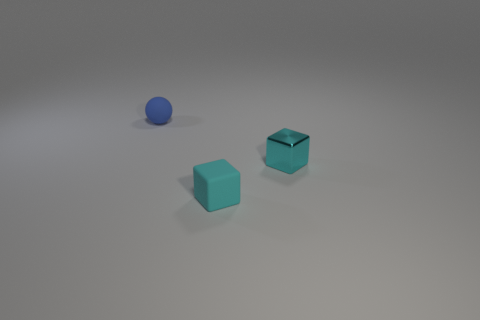How does the lighting affect the appearance of the objects? The lighting in the image creates soft shadows behind the objects, emphasizing their three-dimensional form and enhancing the muted colors of the surfaces. This subtle lighting adds depth and a sense of quiet atmosphere to the scene. 